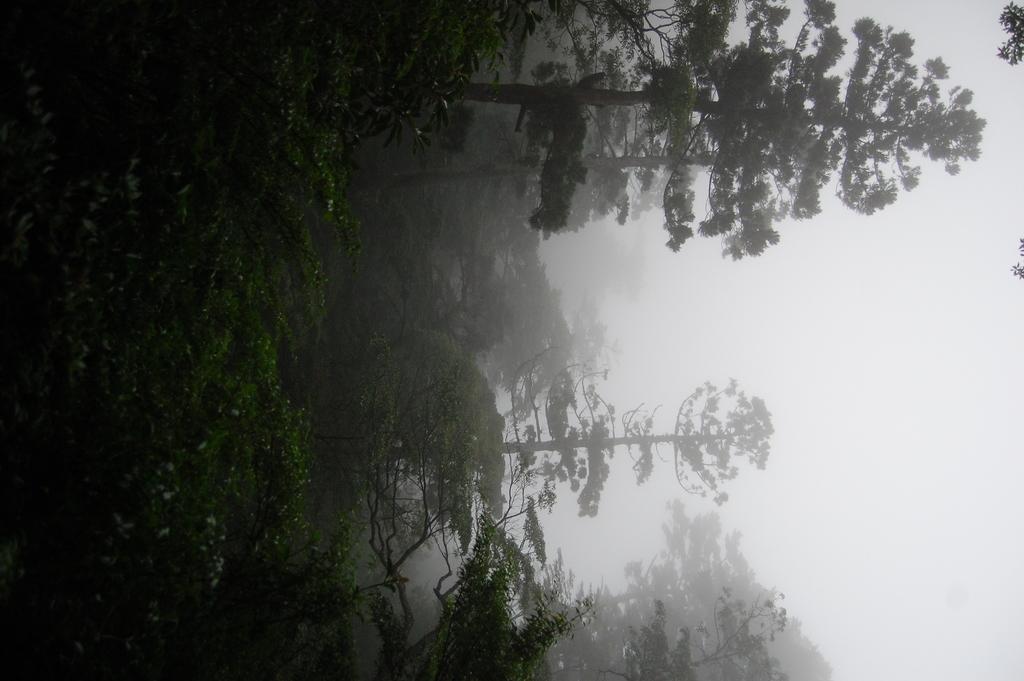What type of vegetation can be seen in the image? There are trees in the image. How many sisters are playing with the pets in the image? There are no sisters or pets present in the image; it only features trees. What type of stretch can be seen in the image? There is no stretch visible in the image; it only features trees. 